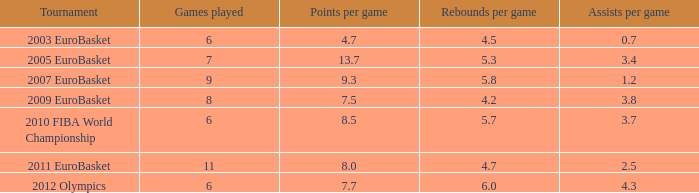How many assists per match are there with 4.3. 